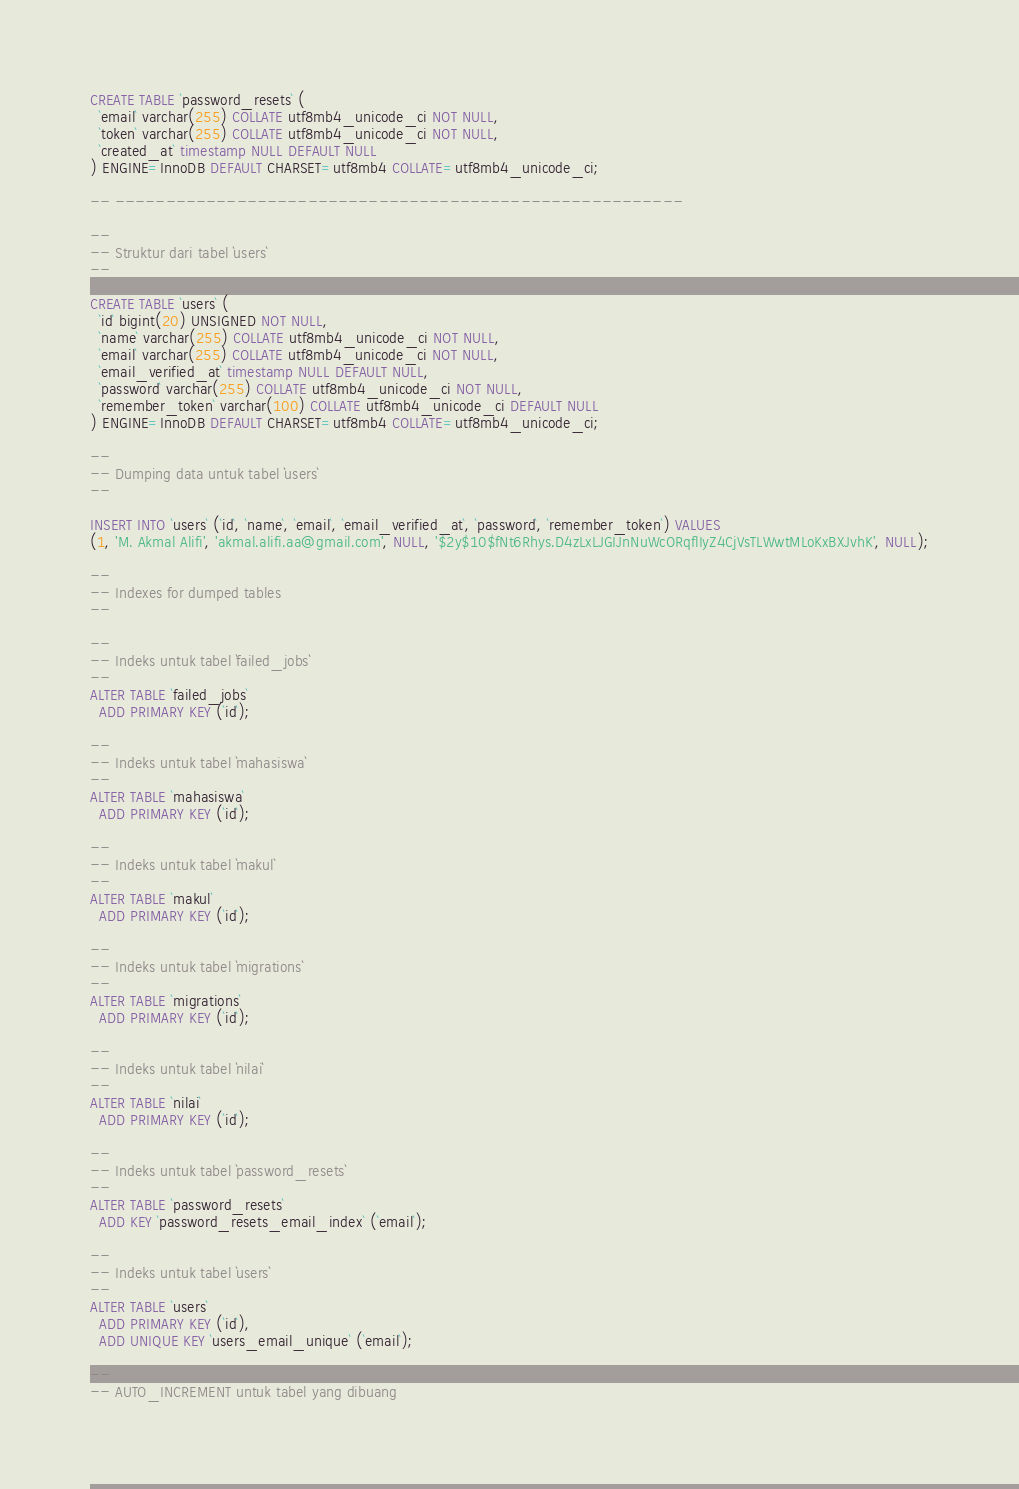Convert code to text. <code><loc_0><loc_0><loc_500><loc_500><_SQL_>
CREATE TABLE `password_resets` (
  `email` varchar(255) COLLATE utf8mb4_unicode_ci NOT NULL,
  `token` varchar(255) COLLATE utf8mb4_unicode_ci NOT NULL,
  `created_at` timestamp NULL DEFAULT NULL
) ENGINE=InnoDB DEFAULT CHARSET=utf8mb4 COLLATE=utf8mb4_unicode_ci;

-- --------------------------------------------------------

--
-- Struktur dari tabel `users`
--

CREATE TABLE `users` (
  `id` bigint(20) UNSIGNED NOT NULL,
  `name` varchar(255) COLLATE utf8mb4_unicode_ci NOT NULL,
  `email` varchar(255) COLLATE utf8mb4_unicode_ci NOT NULL,
  `email_verified_at` timestamp NULL DEFAULT NULL,
  `password` varchar(255) COLLATE utf8mb4_unicode_ci NOT NULL,
  `remember_token` varchar(100) COLLATE utf8mb4_unicode_ci DEFAULT NULL
) ENGINE=InnoDB DEFAULT CHARSET=utf8mb4 COLLATE=utf8mb4_unicode_ci;

--
-- Dumping data untuk tabel `users`
--

INSERT INTO `users` (`id`, `name`, `email`, `email_verified_at`, `password`, `remember_token`) VALUES
(1, 'M. Akmal Alifi', 'akmal.alifi.aa@gmail.com', NULL, '$2y$10$fNt6Rhys.D4zLxLJGIJnNuWcORqflIyZ4CjVsTLWwtMLoKxBXJvhK', NULL);

--
-- Indexes for dumped tables
--

--
-- Indeks untuk tabel `failed_jobs`
--
ALTER TABLE `failed_jobs`
  ADD PRIMARY KEY (`id`);

--
-- Indeks untuk tabel `mahasiswa`
--
ALTER TABLE `mahasiswa`
  ADD PRIMARY KEY (`id`);

--
-- Indeks untuk tabel `makul`
--
ALTER TABLE `makul`
  ADD PRIMARY KEY (`id`);

--
-- Indeks untuk tabel `migrations`
--
ALTER TABLE `migrations`
  ADD PRIMARY KEY (`id`);

--
-- Indeks untuk tabel `nilai`
--
ALTER TABLE `nilai`
  ADD PRIMARY KEY (`id`);

--
-- Indeks untuk tabel `password_resets`
--
ALTER TABLE `password_resets`
  ADD KEY `password_resets_email_index` (`email`);

--
-- Indeks untuk tabel `users`
--
ALTER TABLE `users`
  ADD PRIMARY KEY (`id`),
  ADD UNIQUE KEY `users_email_unique` (`email`);

--
-- AUTO_INCREMENT untuk tabel yang dibuang</code> 